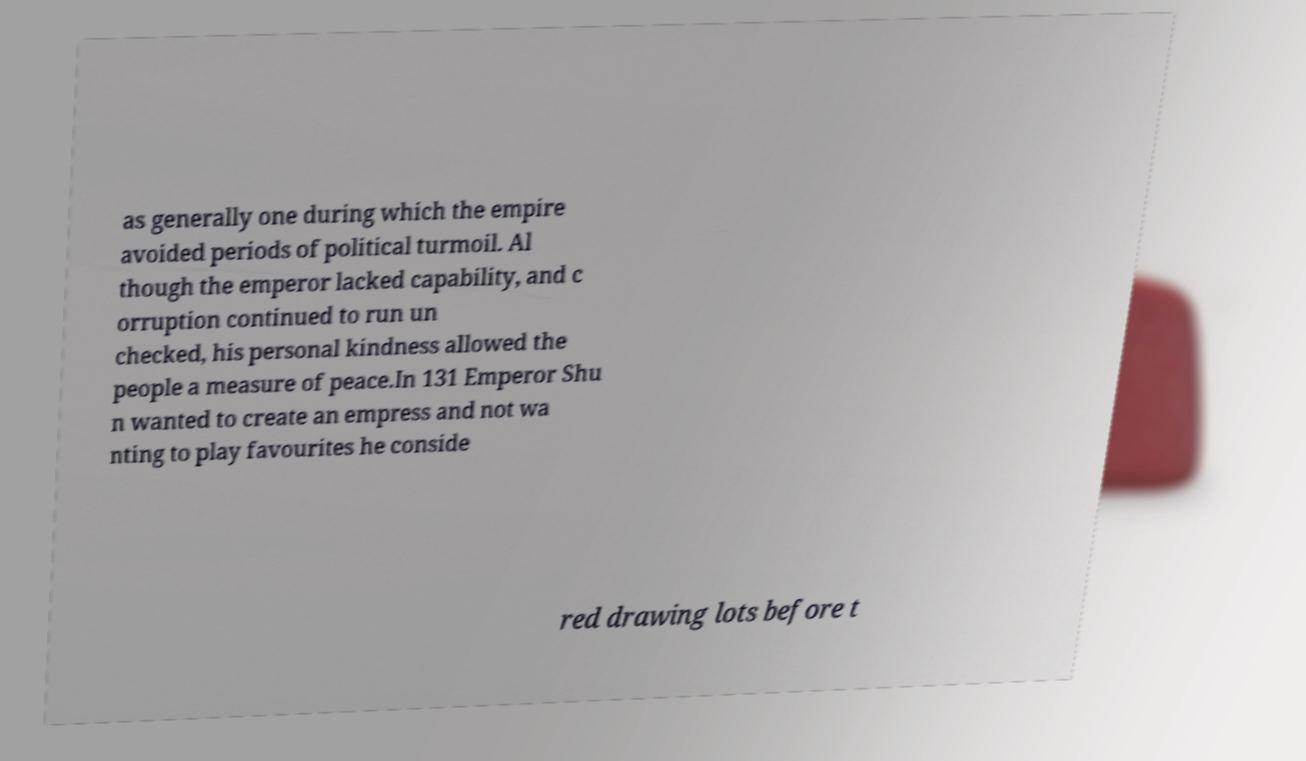Can you read and provide the text displayed in the image?This photo seems to have some interesting text. Can you extract and type it out for me? as generally one during which the empire avoided periods of political turmoil. Al though the emperor lacked capability, and c orruption continued to run un checked, his personal kindness allowed the people a measure of peace.In 131 Emperor Shu n wanted to create an empress and not wa nting to play favourites he conside red drawing lots before t 